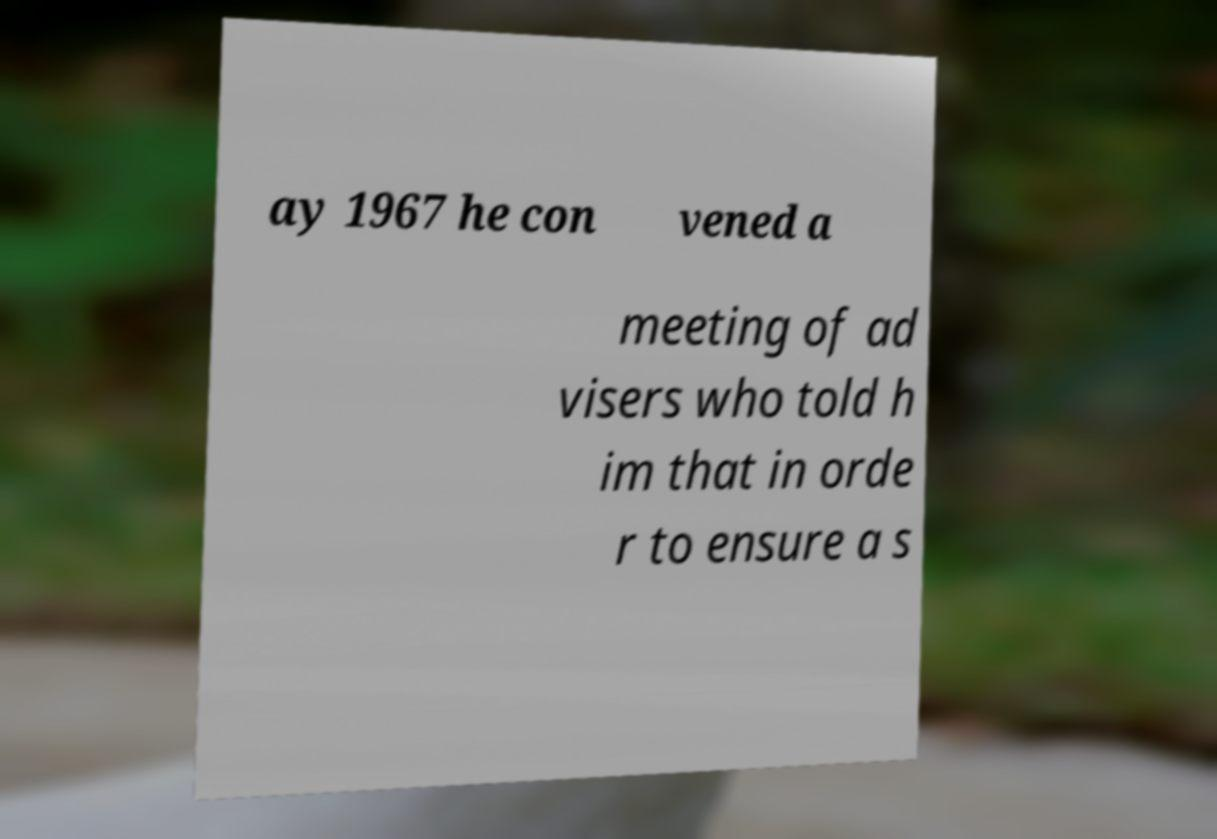Can you accurately transcribe the text from the provided image for me? ay 1967 he con vened a meeting of ad visers who told h im that in orde r to ensure a s 